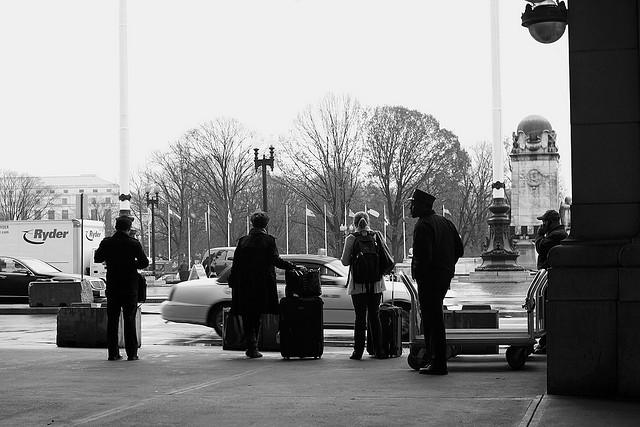What building did the people come from? airport 